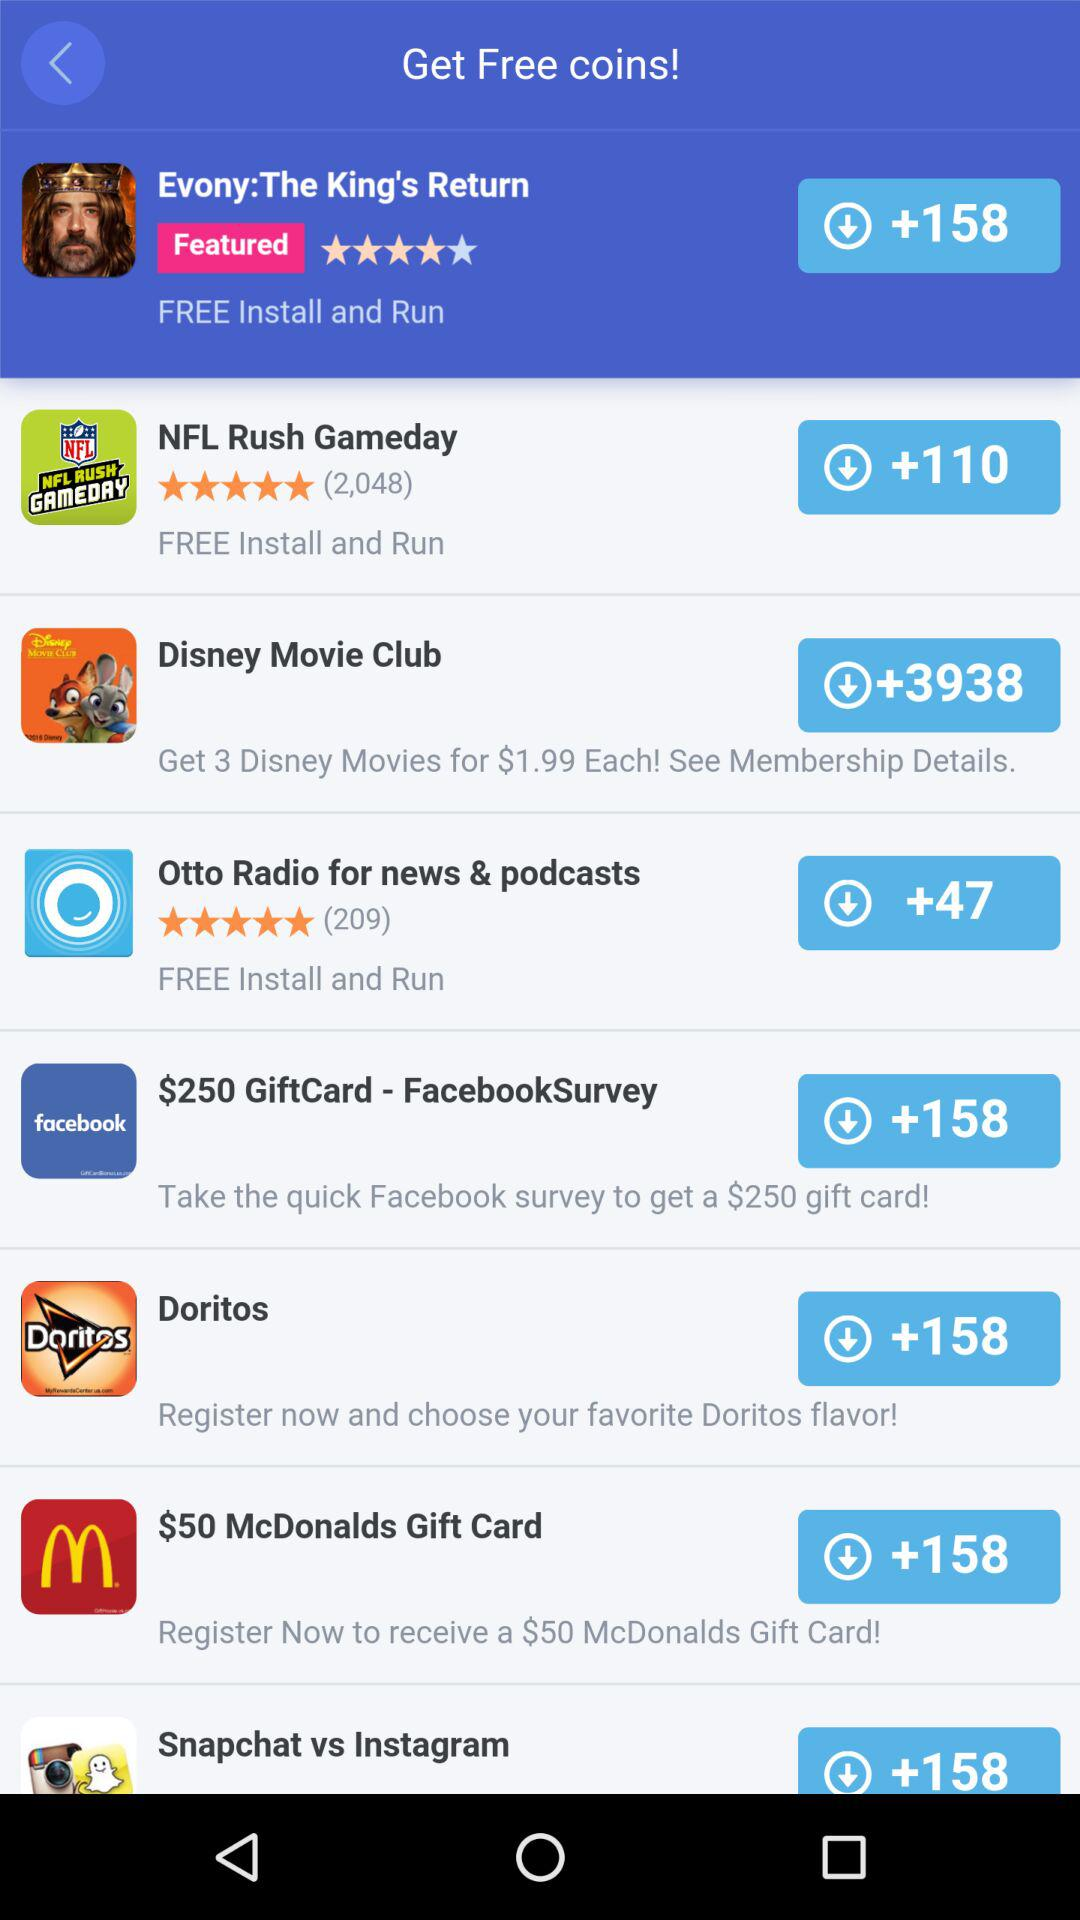What is the number of coins that can be received after installing and running "Evony:The King's Return The number of coins that can be received after installing and running "Evony:The King's Return" is +158. 